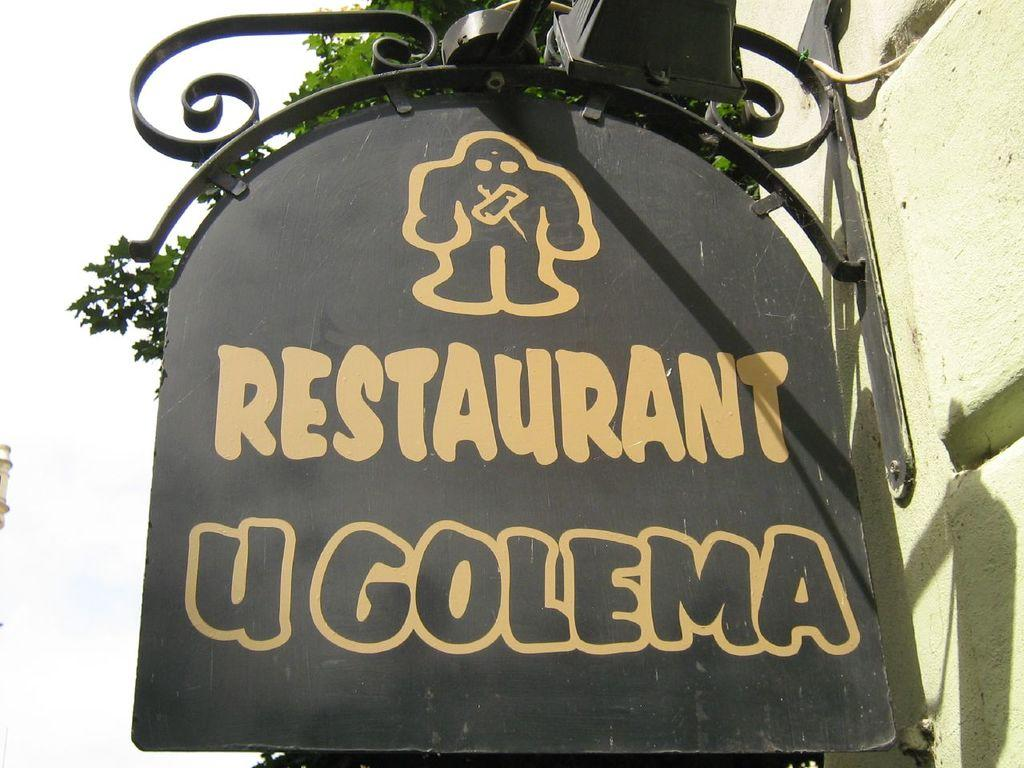What is the main object in the image? There is a name board in the image. How is the name board attached to the wall? The name board is fixed to a wall. What feature can be seen on the name board? There is an iron grill on the name board. What can be seen in the background of the image? There is a tree and the sky visible in the background of the image. How many worms can be seen crawling on the name board in the image? There are no worms present in the image; the focus is on the name board and its features. 